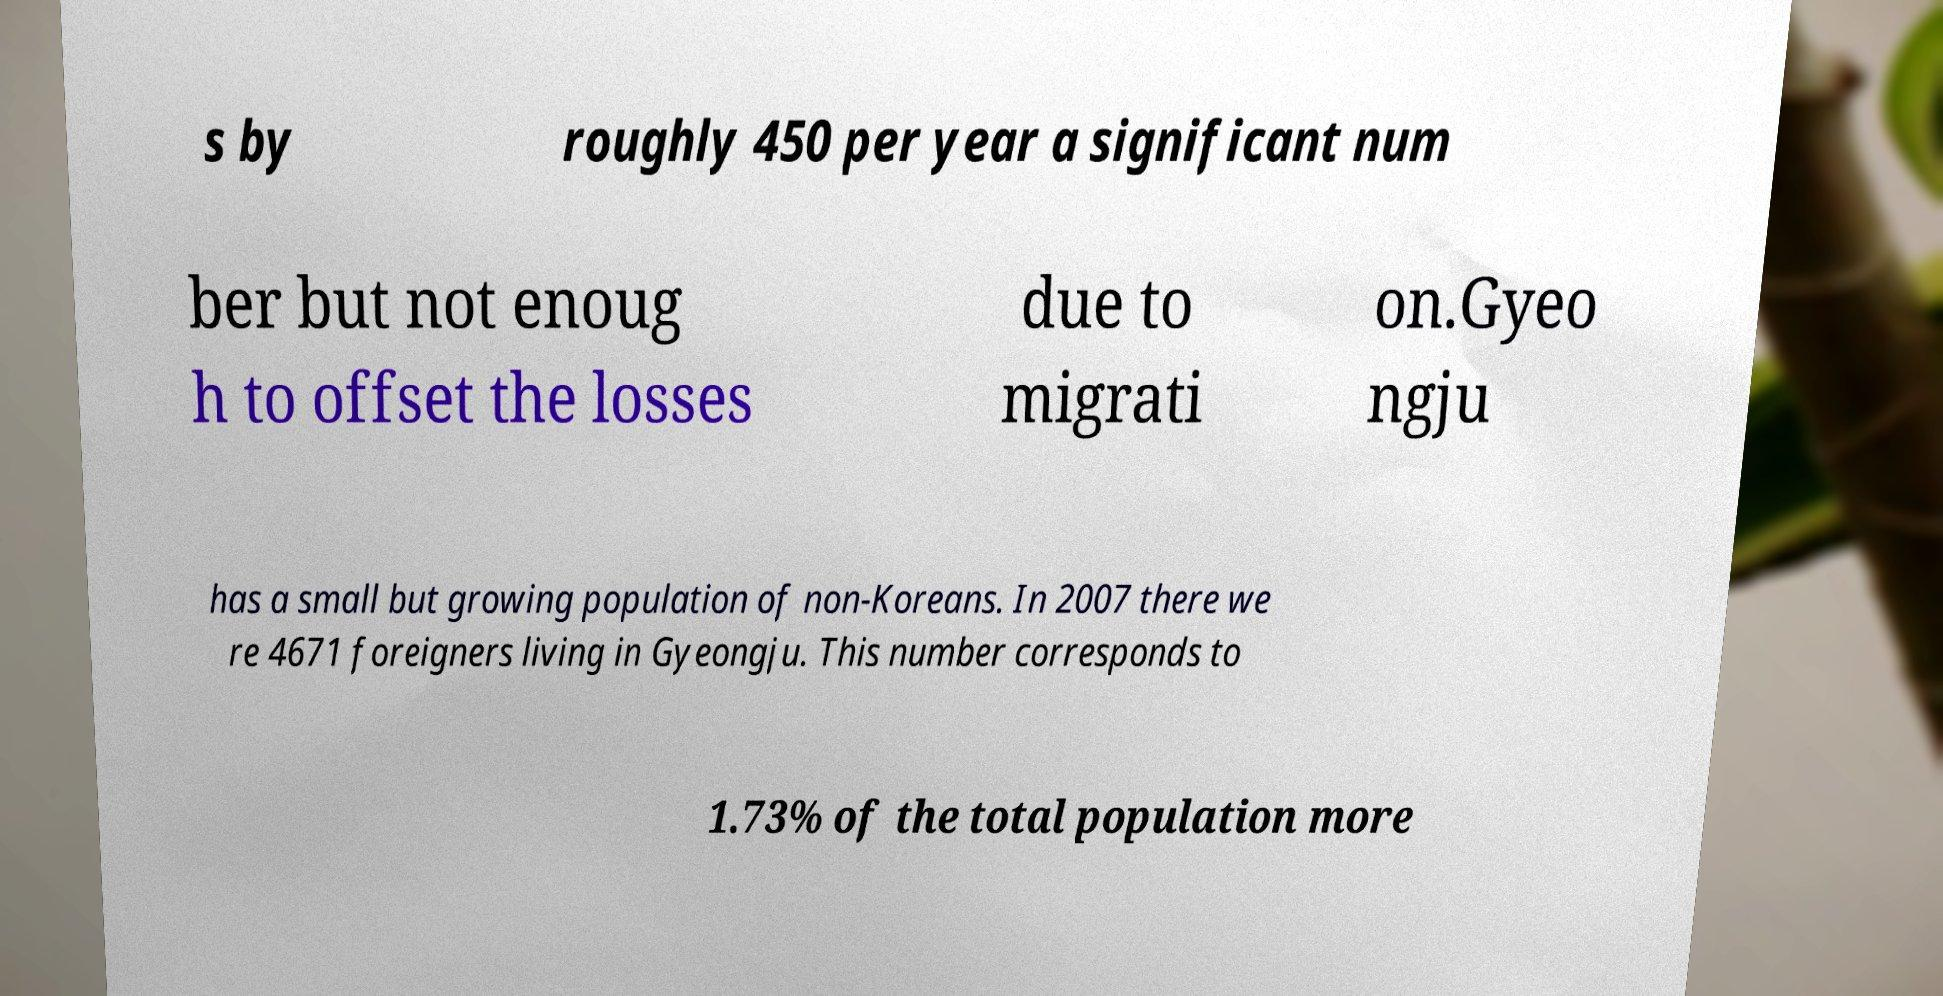Can you accurately transcribe the text from the provided image for me? s by roughly 450 per year a significant num ber but not enoug h to offset the losses due to migrati on.Gyeo ngju has a small but growing population of non-Koreans. In 2007 there we re 4671 foreigners living in Gyeongju. This number corresponds to 1.73% of the total population more 